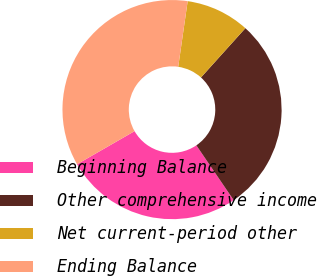<chart> <loc_0><loc_0><loc_500><loc_500><pie_chart><fcel>Beginning Balance<fcel>Other comprehensive income<fcel>Net current-period other<fcel>Ending Balance<nl><fcel>26.2%<fcel>28.82%<fcel>9.39%<fcel>35.59%<nl></chart> 